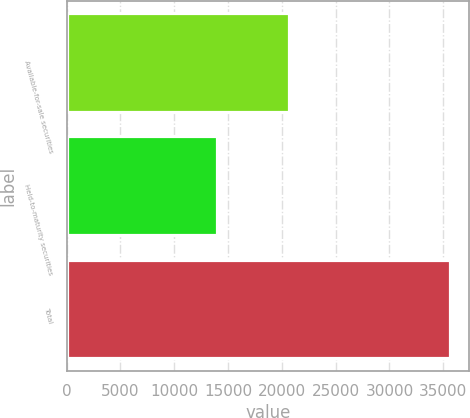<chart> <loc_0><loc_0><loc_500><loc_500><bar_chart><fcel>Available-for-sale securities<fcel>Held-to-maturity securities<fcel>Total<nl><fcel>20620<fcel>14009<fcel>35645<nl></chart> 